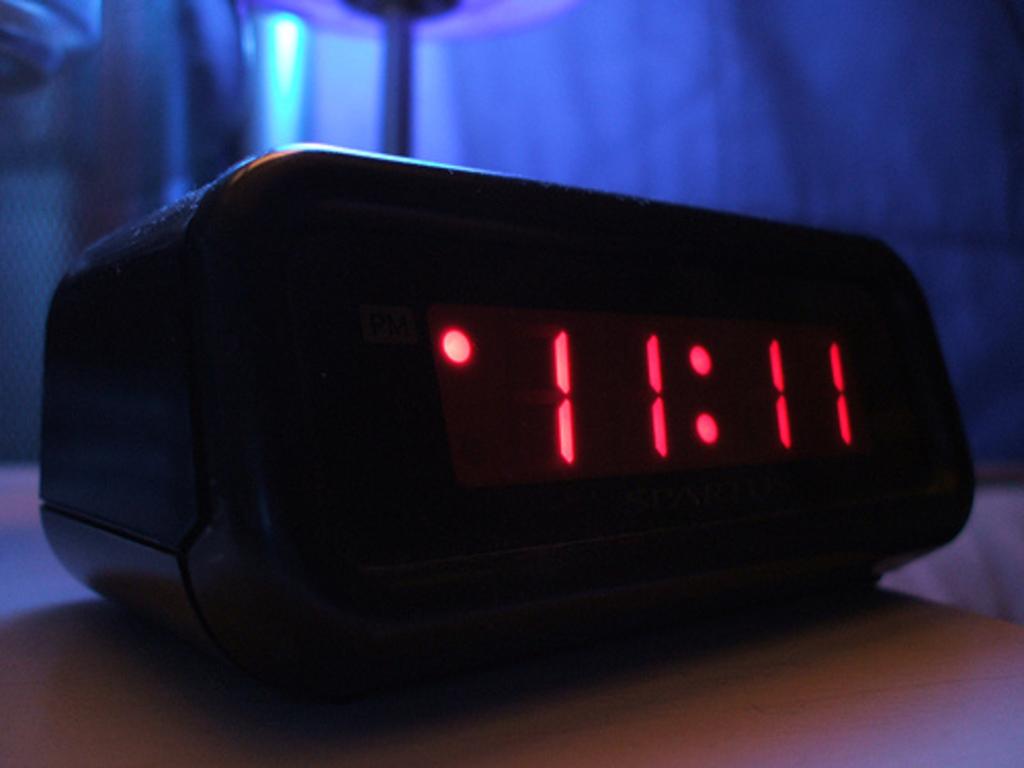What time is it on the clock?
Keep it short and to the point. 11:11. 